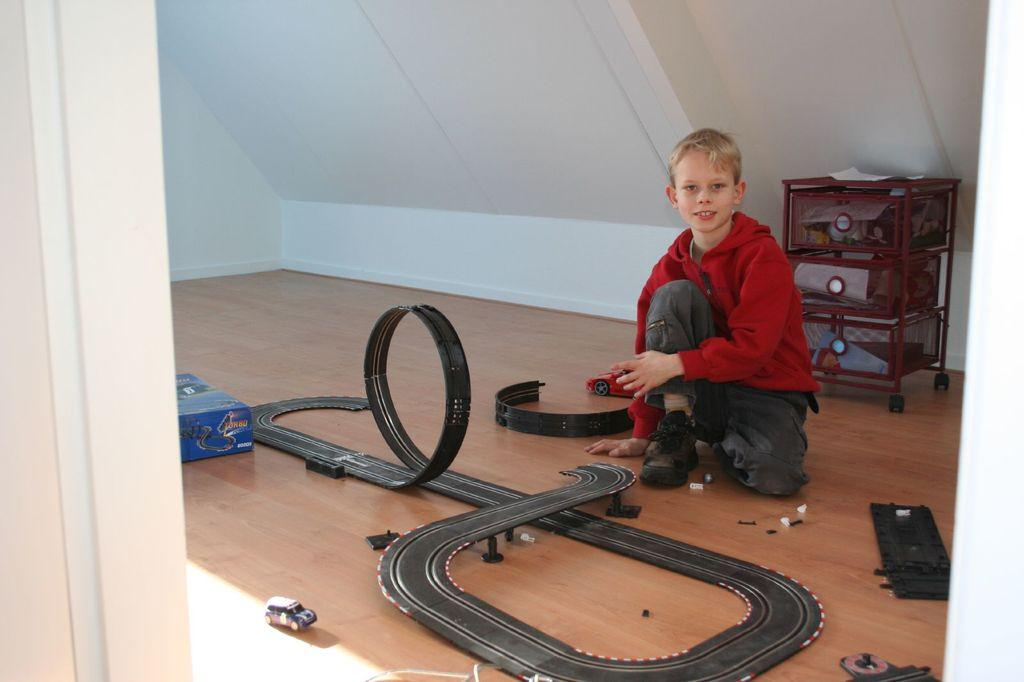Who is the main subject in the image? There is a boy in the image. What is the boy wearing? The boy is wearing a red hood. Where is the boy located in the image? The boy is on a path. What items are in front of the boy? There are toys and a box in front of the boy. What is behind the boy? There is an object behind the boy. What can be seen on the wall behind the boy? There is a white wall behind the boy. Can you see a beggar asking for money in the image? There is no beggar asking for money in the image. How does the wind affect the boy's hood in the image? The image does not show any wind, so it cannot be determined how the wind might affect the boy's hood. 